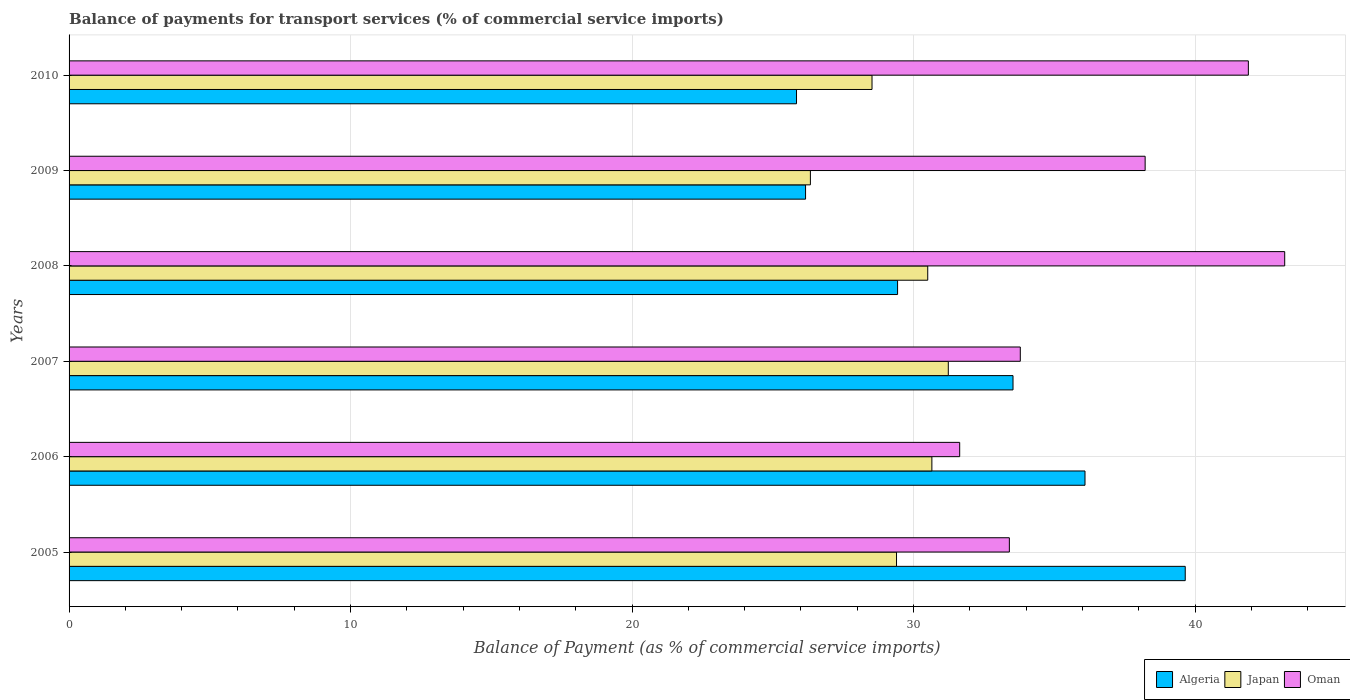How many different coloured bars are there?
Provide a short and direct response. 3. Are the number of bars on each tick of the Y-axis equal?
Offer a terse response. Yes. What is the label of the 1st group of bars from the top?
Ensure brevity in your answer.  2010. What is the balance of payments for transport services in Oman in 2010?
Offer a terse response. 41.89. Across all years, what is the maximum balance of payments for transport services in Oman?
Give a very brief answer. 43.19. Across all years, what is the minimum balance of payments for transport services in Algeria?
Provide a short and direct response. 25.84. In which year was the balance of payments for transport services in Oman minimum?
Your answer should be compact. 2006. What is the total balance of payments for transport services in Oman in the graph?
Your answer should be compact. 222.14. What is the difference between the balance of payments for transport services in Japan in 2006 and that in 2010?
Provide a short and direct response. 2.13. What is the difference between the balance of payments for transport services in Oman in 2005 and the balance of payments for transport services in Japan in 2008?
Give a very brief answer. 2.9. What is the average balance of payments for transport services in Algeria per year?
Make the answer very short. 31.79. In the year 2007, what is the difference between the balance of payments for transport services in Oman and balance of payments for transport services in Algeria?
Ensure brevity in your answer.  0.26. In how many years, is the balance of payments for transport services in Japan greater than 30 %?
Ensure brevity in your answer.  3. What is the ratio of the balance of payments for transport services in Algeria in 2005 to that in 2007?
Keep it short and to the point. 1.18. Is the difference between the balance of payments for transport services in Oman in 2007 and 2008 greater than the difference between the balance of payments for transport services in Algeria in 2007 and 2008?
Provide a short and direct response. No. What is the difference between the highest and the second highest balance of payments for transport services in Japan?
Provide a succinct answer. 0.58. What is the difference between the highest and the lowest balance of payments for transport services in Oman?
Make the answer very short. 11.55. Is the sum of the balance of payments for transport services in Oman in 2009 and 2010 greater than the maximum balance of payments for transport services in Algeria across all years?
Your answer should be very brief. Yes. What does the 1st bar from the top in 2010 represents?
Your answer should be very brief. Oman. What does the 3rd bar from the bottom in 2008 represents?
Your response must be concise. Oman. Are the values on the major ticks of X-axis written in scientific E-notation?
Provide a short and direct response. No. Does the graph contain any zero values?
Ensure brevity in your answer.  No. Does the graph contain grids?
Ensure brevity in your answer.  Yes. Where does the legend appear in the graph?
Make the answer very short. Bottom right. How many legend labels are there?
Ensure brevity in your answer.  3. How are the legend labels stacked?
Offer a very short reply. Horizontal. What is the title of the graph?
Provide a succinct answer. Balance of payments for transport services (% of commercial service imports). Does "Cote d'Ivoire" appear as one of the legend labels in the graph?
Ensure brevity in your answer.  No. What is the label or title of the X-axis?
Your answer should be compact. Balance of Payment (as % of commercial service imports). What is the label or title of the Y-axis?
Make the answer very short. Years. What is the Balance of Payment (as % of commercial service imports) of Algeria in 2005?
Provide a succinct answer. 39.65. What is the Balance of Payment (as % of commercial service imports) of Japan in 2005?
Ensure brevity in your answer.  29.4. What is the Balance of Payment (as % of commercial service imports) in Oman in 2005?
Your response must be concise. 33.4. What is the Balance of Payment (as % of commercial service imports) of Algeria in 2006?
Offer a very short reply. 36.09. What is the Balance of Payment (as % of commercial service imports) of Japan in 2006?
Offer a terse response. 30.65. What is the Balance of Payment (as % of commercial service imports) in Oman in 2006?
Keep it short and to the point. 31.64. What is the Balance of Payment (as % of commercial service imports) of Algeria in 2007?
Give a very brief answer. 33.53. What is the Balance of Payment (as % of commercial service imports) in Japan in 2007?
Your response must be concise. 31.23. What is the Balance of Payment (as % of commercial service imports) in Oman in 2007?
Offer a terse response. 33.79. What is the Balance of Payment (as % of commercial service imports) in Algeria in 2008?
Your answer should be very brief. 29.43. What is the Balance of Payment (as % of commercial service imports) in Japan in 2008?
Your answer should be very brief. 30.5. What is the Balance of Payment (as % of commercial service imports) of Oman in 2008?
Your answer should be compact. 43.19. What is the Balance of Payment (as % of commercial service imports) of Algeria in 2009?
Keep it short and to the point. 26.16. What is the Balance of Payment (as % of commercial service imports) in Japan in 2009?
Give a very brief answer. 26.34. What is the Balance of Payment (as % of commercial service imports) in Oman in 2009?
Your answer should be compact. 38.23. What is the Balance of Payment (as % of commercial service imports) in Algeria in 2010?
Offer a very short reply. 25.84. What is the Balance of Payment (as % of commercial service imports) in Japan in 2010?
Offer a terse response. 28.52. What is the Balance of Payment (as % of commercial service imports) in Oman in 2010?
Your response must be concise. 41.89. Across all years, what is the maximum Balance of Payment (as % of commercial service imports) in Algeria?
Give a very brief answer. 39.65. Across all years, what is the maximum Balance of Payment (as % of commercial service imports) of Japan?
Your answer should be compact. 31.23. Across all years, what is the maximum Balance of Payment (as % of commercial service imports) of Oman?
Offer a very short reply. 43.19. Across all years, what is the minimum Balance of Payment (as % of commercial service imports) in Algeria?
Provide a short and direct response. 25.84. Across all years, what is the minimum Balance of Payment (as % of commercial service imports) of Japan?
Offer a very short reply. 26.34. Across all years, what is the minimum Balance of Payment (as % of commercial service imports) of Oman?
Your answer should be compact. 31.64. What is the total Balance of Payment (as % of commercial service imports) of Algeria in the graph?
Your answer should be very brief. 190.72. What is the total Balance of Payment (as % of commercial service imports) of Japan in the graph?
Your response must be concise. 176.65. What is the total Balance of Payment (as % of commercial service imports) in Oman in the graph?
Offer a terse response. 222.14. What is the difference between the Balance of Payment (as % of commercial service imports) in Algeria in 2005 and that in 2006?
Provide a succinct answer. 3.56. What is the difference between the Balance of Payment (as % of commercial service imports) in Japan in 2005 and that in 2006?
Ensure brevity in your answer.  -1.26. What is the difference between the Balance of Payment (as % of commercial service imports) in Oman in 2005 and that in 2006?
Your answer should be compact. 1.76. What is the difference between the Balance of Payment (as % of commercial service imports) of Algeria in 2005 and that in 2007?
Provide a succinct answer. 6.12. What is the difference between the Balance of Payment (as % of commercial service imports) in Japan in 2005 and that in 2007?
Your answer should be very brief. -1.84. What is the difference between the Balance of Payment (as % of commercial service imports) in Oman in 2005 and that in 2007?
Ensure brevity in your answer.  -0.39. What is the difference between the Balance of Payment (as % of commercial service imports) of Algeria in 2005 and that in 2008?
Provide a succinct answer. 10.22. What is the difference between the Balance of Payment (as % of commercial service imports) in Japan in 2005 and that in 2008?
Provide a short and direct response. -1.11. What is the difference between the Balance of Payment (as % of commercial service imports) in Oman in 2005 and that in 2008?
Keep it short and to the point. -9.78. What is the difference between the Balance of Payment (as % of commercial service imports) of Algeria in 2005 and that in 2009?
Provide a short and direct response. 13.49. What is the difference between the Balance of Payment (as % of commercial service imports) of Japan in 2005 and that in 2009?
Give a very brief answer. 3.06. What is the difference between the Balance of Payment (as % of commercial service imports) of Oman in 2005 and that in 2009?
Your answer should be compact. -4.82. What is the difference between the Balance of Payment (as % of commercial service imports) of Algeria in 2005 and that in 2010?
Keep it short and to the point. 13.81. What is the difference between the Balance of Payment (as % of commercial service imports) in Japan in 2005 and that in 2010?
Your answer should be very brief. 0.87. What is the difference between the Balance of Payment (as % of commercial service imports) of Oman in 2005 and that in 2010?
Ensure brevity in your answer.  -8.49. What is the difference between the Balance of Payment (as % of commercial service imports) of Algeria in 2006 and that in 2007?
Give a very brief answer. 2.56. What is the difference between the Balance of Payment (as % of commercial service imports) in Japan in 2006 and that in 2007?
Provide a succinct answer. -0.58. What is the difference between the Balance of Payment (as % of commercial service imports) in Oman in 2006 and that in 2007?
Provide a short and direct response. -2.15. What is the difference between the Balance of Payment (as % of commercial service imports) of Algeria in 2006 and that in 2008?
Ensure brevity in your answer.  6.66. What is the difference between the Balance of Payment (as % of commercial service imports) in Japan in 2006 and that in 2008?
Your answer should be very brief. 0.15. What is the difference between the Balance of Payment (as % of commercial service imports) in Oman in 2006 and that in 2008?
Offer a terse response. -11.55. What is the difference between the Balance of Payment (as % of commercial service imports) in Algeria in 2006 and that in 2009?
Your response must be concise. 9.93. What is the difference between the Balance of Payment (as % of commercial service imports) in Japan in 2006 and that in 2009?
Your answer should be very brief. 4.32. What is the difference between the Balance of Payment (as % of commercial service imports) of Oman in 2006 and that in 2009?
Your response must be concise. -6.59. What is the difference between the Balance of Payment (as % of commercial service imports) of Algeria in 2006 and that in 2010?
Make the answer very short. 10.25. What is the difference between the Balance of Payment (as % of commercial service imports) in Japan in 2006 and that in 2010?
Your answer should be very brief. 2.13. What is the difference between the Balance of Payment (as % of commercial service imports) in Oman in 2006 and that in 2010?
Make the answer very short. -10.26. What is the difference between the Balance of Payment (as % of commercial service imports) of Algeria in 2007 and that in 2008?
Provide a succinct answer. 4.1. What is the difference between the Balance of Payment (as % of commercial service imports) in Japan in 2007 and that in 2008?
Your response must be concise. 0.73. What is the difference between the Balance of Payment (as % of commercial service imports) in Oman in 2007 and that in 2008?
Provide a short and direct response. -9.39. What is the difference between the Balance of Payment (as % of commercial service imports) of Algeria in 2007 and that in 2009?
Provide a succinct answer. 7.37. What is the difference between the Balance of Payment (as % of commercial service imports) of Japan in 2007 and that in 2009?
Your answer should be compact. 4.9. What is the difference between the Balance of Payment (as % of commercial service imports) in Oman in 2007 and that in 2009?
Offer a very short reply. -4.44. What is the difference between the Balance of Payment (as % of commercial service imports) of Algeria in 2007 and that in 2010?
Offer a terse response. 7.69. What is the difference between the Balance of Payment (as % of commercial service imports) in Japan in 2007 and that in 2010?
Offer a terse response. 2.71. What is the difference between the Balance of Payment (as % of commercial service imports) of Oman in 2007 and that in 2010?
Your answer should be very brief. -8.1. What is the difference between the Balance of Payment (as % of commercial service imports) of Algeria in 2008 and that in 2009?
Ensure brevity in your answer.  3.27. What is the difference between the Balance of Payment (as % of commercial service imports) of Japan in 2008 and that in 2009?
Ensure brevity in your answer.  4.17. What is the difference between the Balance of Payment (as % of commercial service imports) in Oman in 2008 and that in 2009?
Provide a succinct answer. 4.96. What is the difference between the Balance of Payment (as % of commercial service imports) in Algeria in 2008 and that in 2010?
Your answer should be compact. 3.59. What is the difference between the Balance of Payment (as % of commercial service imports) in Japan in 2008 and that in 2010?
Your answer should be compact. 1.98. What is the difference between the Balance of Payment (as % of commercial service imports) in Oman in 2008 and that in 2010?
Offer a very short reply. 1.29. What is the difference between the Balance of Payment (as % of commercial service imports) of Algeria in 2009 and that in 2010?
Your response must be concise. 0.32. What is the difference between the Balance of Payment (as % of commercial service imports) of Japan in 2009 and that in 2010?
Your answer should be compact. -2.19. What is the difference between the Balance of Payment (as % of commercial service imports) of Oman in 2009 and that in 2010?
Make the answer very short. -3.67. What is the difference between the Balance of Payment (as % of commercial service imports) in Algeria in 2005 and the Balance of Payment (as % of commercial service imports) in Japan in 2006?
Provide a short and direct response. 9. What is the difference between the Balance of Payment (as % of commercial service imports) of Algeria in 2005 and the Balance of Payment (as % of commercial service imports) of Oman in 2006?
Offer a very short reply. 8.01. What is the difference between the Balance of Payment (as % of commercial service imports) in Japan in 2005 and the Balance of Payment (as % of commercial service imports) in Oman in 2006?
Your answer should be compact. -2.24. What is the difference between the Balance of Payment (as % of commercial service imports) in Algeria in 2005 and the Balance of Payment (as % of commercial service imports) in Japan in 2007?
Your response must be concise. 8.42. What is the difference between the Balance of Payment (as % of commercial service imports) of Algeria in 2005 and the Balance of Payment (as % of commercial service imports) of Oman in 2007?
Your answer should be very brief. 5.86. What is the difference between the Balance of Payment (as % of commercial service imports) in Japan in 2005 and the Balance of Payment (as % of commercial service imports) in Oman in 2007?
Your answer should be very brief. -4.4. What is the difference between the Balance of Payment (as % of commercial service imports) in Algeria in 2005 and the Balance of Payment (as % of commercial service imports) in Japan in 2008?
Make the answer very short. 9.15. What is the difference between the Balance of Payment (as % of commercial service imports) in Algeria in 2005 and the Balance of Payment (as % of commercial service imports) in Oman in 2008?
Ensure brevity in your answer.  -3.53. What is the difference between the Balance of Payment (as % of commercial service imports) of Japan in 2005 and the Balance of Payment (as % of commercial service imports) of Oman in 2008?
Provide a short and direct response. -13.79. What is the difference between the Balance of Payment (as % of commercial service imports) in Algeria in 2005 and the Balance of Payment (as % of commercial service imports) in Japan in 2009?
Give a very brief answer. 13.32. What is the difference between the Balance of Payment (as % of commercial service imports) of Algeria in 2005 and the Balance of Payment (as % of commercial service imports) of Oman in 2009?
Offer a very short reply. 1.42. What is the difference between the Balance of Payment (as % of commercial service imports) of Japan in 2005 and the Balance of Payment (as % of commercial service imports) of Oman in 2009?
Your response must be concise. -8.83. What is the difference between the Balance of Payment (as % of commercial service imports) of Algeria in 2005 and the Balance of Payment (as % of commercial service imports) of Japan in 2010?
Provide a succinct answer. 11.13. What is the difference between the Balance of Payment (as % of commercial service imports) in Algeria in 2005 and the Balance of Payment (as % of commercial service imports) in Oman in 2010?
Your answer should be very brief. -2.24. What is the difference between the Balance of Payment (as % of commercial service imports) of Japan in 2005 and the Balance of Payment (as % of commercial service imports) of Oman in 2010?
Keep it short and to the point. -12.5. What is the difference between the Balance of Payment (as % of commercial service imports) in Algeria in 2006 and the Balance of Payment (as % of commercial service imports) in Japan in 2007?
Offer a very short reply. 4.86. What is the difference between the Balance of Payment (as % of commercial service imports) in Algeria in 2006 and the Balance of Payment (as % of commercial service imports) in Oman in 2007?
Your answer should be very brief. 2.3. What is the difference between the Balance of Payment (as % of commercial service imports) in Japan in 2006 and the Balance of Payment (as % of commercial service imports) in Oman in 2007?
Offer a terse response. -3.14. What is the difference between the Balance of Payment (as % of commercial service imports) of Algeria in 2006 and the Balance of Payment (as % of commercial service imports) of Japan in 2008?
Make the answer very short. 5.59. What is the difference between the Balance of Payment (as % of commercial service imports) of Algeria in 2006 and the Balance of Payment (as % of commercial service imports) of Oman in 2008?
Make the answer very short. -7.09. What is the difference between the Balance of Payment (as % of commercial service imports) of Japan in 2006 and the Balance of Payment (as % of commercial service imports) of Oman in 2008?
Make the answer very short. -12.53. What is the difference between the Balance of Payment (as % of commercial service imports) in Algeria in 2006 and the Balance of Payment (as % of commercial service imports) in Japan in 2009?
Offer a very short reply. 9.76. What is the difference between the Balance of Payment (as % of commercial service imports) of Algeria in 2006 and the Balance of Payment (as % of commercial service imports) of Oman in 2009?
Your response must be concise. -2.14. What is the difference between the Balance of Payment (as % of commercial service imports) in Japan in 2006 and the Balance of Payment (as % of commercial service imports) in Oman in 2009?
Provide a short and direct response. -7.58. What is the difference between the Balance of Payment (as % of commercial service imports) of Algeria in 2006 and the Balance of Payment (as % of commercial service imports) of Japan in 2010?
Offer a terse response. 7.57. What is the difference between the Balance of Payment (as % of commercial service imports) in Algeria in 2006 and the Balance of Payment (as % of commercial service imports) in Oman in 2010?
Keep it short and to the point. -5.8. What is the difference between the Balance of Payment (as % of commercial service imports) in Japan in 2006 and the Balance of Payment (as % of commercial service imports) in Oman in 2010?
Make the answer very short. -11.24. What is the difference between the Balance of Payment (as % of commercial service imports) of Algeria in 2007 and the Balance of Payment (as % of commercial service imports) of Japan in 2008?
Provide a succinct answer. 3.03. What is the difference between the Balance of Payment (as % of commercial service imports) in Algeria in 2007 and the Balance of Payment (as % of commercial service imports) in Oman in 2008?
Provide a succinct answer. -9.65. What is the difference between the Balance of Payment (as % of commercial service imports) of Japan in 2007 and the Balance of Payment (as % of commercial service imports) of Oman in 2008?
Your answer should be very brief. -11.95. What is the difference between the Balance of Payment (as % of commercial service imports) of Algeria in 2007 and the Balance of Payment (as % of commercial service imports) of Japan in 2009?
Provide a succinct answer. 7.2. What is the difference between the Balance of Payment (as % of commercial service imports) of Algeria in 2007 and the Balance of Payment (as % of commercial service imports) of Oman in 2009?
Your response must be concise. -4.69. What is the difference between the Balance of Payment (as % of commercial service imports) of Japan in 2007 and the Balance of Payment (as % of commercial service imports) of Oman in 2009?
Give a very brief answer. -6.99. What is the difference between the Balance of Payment (as % of commercial service imports) in Algeria in 2007 and the Balance of Payment (as % of commercial service imports) in Japan in 2010?
Offer a terse response. 5.01. What is the difference between the Balance of Payment (as % of commercial service imports) in Algeria in 2007 and the Balance of Payment (as % of commercial service imports) in Oman in 2010?
Your answer should be compact. -8.36. What is the difference between the Balance of Payment (as % of commercial service imports) of Japan in 2007 and the Balance of Payment (as % of commercial service imports) of Oman in 2010?
Provide a short and direct response. -10.66. What is the difference between the Balance of Payment (as % of commercial service imports) of Algeria in 2008 and the Balance of Payment (as % of commercial service imports) of Japan in 2009?
Ensure brevity in your answer.  3.1. What is the difference between the Balance of Payment (as % of commercial service imports) in Algeria in 2008 and the Balance of Payment (as % of commercial service imports) in Oman in 2009?
Your response must be concise. -8.8. What is the difference between the Balance of Payment (as % of commercial service imports) in Japan in 2008 and the Balance of Payment (as % of commercial service imports) in Oman in 2009?
Keep it short and to the point. -7.72. What is the difference between the Balance of Payment (as % of commercial service imports) in Algeria in 2008 and the Balance of Payment (as % of commercial service imports) in Japan in 2010?
Ensure brevity in your answer.  0.91. What is the difference between the Balance of Payment (as % of commercial service imports) in Algeria in 2008 and the Balance of Payment (as % of commercial service imports) in Oman in 2010?
Give a very brief answer. -12.46. What is the difference between the Balance of Payment (as % of commercial service imports) of Japan in 2008 and the Balance of Payment (as % of commercial service imports) of Oman in 2010?
Offer a very short reply. -11.39. What is the difference between the Balance of Payment (as % of commercial service imports) in Algeria in 2009 and the Balance of Payment (as % of commercial service imports) in Japan in 2010?
Provide a short and direct response. -2.36. What is the difference between the Balance of Payment (as % of commercial service imports) in Algeria in 2009 and the Balance of Payment (as % of commercial service imports) in Oman in 2010?
Provide a succinct answer. -15.73. What is the difference between the Balance of Payment (as % of commercial service imports) of Japan in 2009 and the Balance of Payment (as % of commercial service imports) of Oman in 2010?
Ensure brevity in your answer.  -15.56. What is the average Balance of Payment (as % of commercial service imports) of Algeria per year?
Ensure brevity in your answer.  31.79. What is the average Balance of Payment (as % of commercial service imports) of Japan per year?
Your response must be concise. 29.44. What is the average Balance of Payment (as % of commercial service imports) of Oman per year?
Offer a very short reply. 37.02. In the year 2005, what is the difference between the Balance of Payment (as % of commercial service imports) in Algeria and Balance of Payment (as % of commercial service imports) in Japan?
Provide a succinct answer. 10.26. In the year 2005, what is the difference between the Balance of Payment (as % of commercial service imports) of Algeria and Balance of Payment (as % of commercial service imports) of Oman?
Keep it short and to the point. 6.25. In the year 2005, what is the difference between the Balance of Payment (as % of commercial service imports) of Japan and Balance of Payment (as % of commercial service imports) of Oman?
Provide a short and direct response. -4.01. In the year 2006, what is the difference between the Balance of Payment (as % of commercial service imports) in Algeria and Balance of Payment (as % of commercial service imports) in Japan?
Your answer should be compact. 5.44. In the year 2006, what is the difference between the Balance of Payment (as % of commercial service imports) in Algeria and Balance of Payment (as % of commercial service imports) in Oman?
Your answer should be very brief. 4.45. In the year 2006, what is the difference between the Balance of Payment (as % of commercial service imports) in Japan and Balance of Payment (as % of commercial service imports) in Oman?
Provide a succinct answer. -0.99. In the year 2007, what is the difference between the Balance of Payment (as % of commercial service imports) in Algeria and Balance of Payment (as % of commercial service imports) in Japan?
Offer a very short reply. 2.3. In the year 2007, what is the difference between the Balance of Payment (as % of commercial service imports) in Algeria and Balance of Payment (as % of commercial service imports) in Oman?
Offer a terse response. -0.26. In the year 2007, what is the difference between the Balance of Payment (as % of commercial service imports) in Japan and Balance of Payment (as % of commercial service imports) in Oman?
Give a very brief answer. -2.56. In the year 2008, what is the difference between the Balance of Payment (as % of commercial service imports) in Algeria and Balance of Payment (as % of commercial service imports) in Japan?
Your answer should be compact. -1.07. In the year 2008, what is the difference between the Balance of Payment (as % of commercial service imports) in Algeria and Balance of Payment (as % of commercial service imports) in Oman?
Give a very brief answer. -13.75. In the year 2008, what is the difference between the Balance of Payment (as % of commercial service imports) in Japan and Balance of Payment (as % of commercial service imports) in Oman?
Keep it short and to the point. -12.68. In the year 2009, what is the difference between the Balance of Payment (as % of commercial service imports) of Algeria and Balance of Payment (as % of commercial service imports) of Japan?
Your answer should be very brief. -0.17. In the year 2009, what is the difference between the Balance of Payment (as % of commercial service imports) in Algeria and Balance of Payment (as % of commercial service imports) in Oman?
Your answer should be very brief. -12.06. In the year 2009, what is the difference between the Balance of Payment (as % of commercial service imports) in Japan and Balance of Payment (as % of commercial service imports) in Oman?
Ensure brevity in your answer.  -11.89. In the year 2010, what is the difference between the Balance of Payment (as % of commercial service imports) of Algeria and Balance of Payment (as % of commercial service imports) of Japan?
Make the answer very short. -2.68. In the year 2010, what is the difference between the Balance of Payment (as % of commercial service imports) of Algeria and Balance of Payment (as % of commercial service imports) of Oman?
Ensure brevity in your answer.  -16.05. In the year 2010, what is the difference between the Balance of Payment (as % of commercial service imports) of Japan and Balance of Payment (as % of commercial service imports) of Oman?
Make the answer very short. -13.37. What is the ratio of the Balance of Payment (as % of commercial service imports) of Algeria in 2005 to that in 2006?
Your response must be concise. 1.1. What is the ratio of the Balance of Payment (as % of commercial service imports) in Oman in 2005 to that in 2006?
Your answer should be very brief. 1.06. What is the ratio of the Balance of Payment (as % of commercial service imports) in Algeria in 2005 to that in 2007?
Offer a terse response. 1.18. What is the ratio of the Balance of Payment (as % of commercial service imports) in Japan in 2005 to that in 2007?
Your answer should be very brief. 0.94. What is the ratio of the Balance of Payment (as % of commercial service imports) of Algeria in 2005 to that in 2008?
Your answer should be compact. 1.35. What is the ratio of the Balance of Payment (as % of commercial service imports) in Japan in 2005 to that in 2008?
Your response must be concise. 0.96. What is the ratio of the Balance of Payment (as % of commercial service imports) of Oman in 2005 to that in 2008?
Keep it short and to the point. 0.77. What is the ratio of the Balance of Payment (as % of commercial service imports) in Algeria in 2005 to that in 2009?
Provide a succinct answer. 1.52. What is the ratio of the Balance of Payment (as % of commercial service imports) of Japan in 2005 to that in 2009?
Give a very brief answer. 1.12. What is the ratio of the Balance of Payment (as % of commercial service imports) in Oman in 2005 to that in 2009?
Provide a short and direct response. 0.87. What is the ratio of the Balance of Payment (as % of commercial service imports) in Algeria in 2005 to that in 2010?
Provide a short and direct response. 1.53. What is the ratio of the Balance of Payment (as % of commercial service imports) in Japan in 2005 to that in 2010?
Your response must be concise. 1.03. What is the ratio of the Balance of Payment (as % of commercial service imports) in Oman in 2005 to that in 2010?
Ensure brevity in your answer.  0.8. What is the ratio of the Balance of Payment (as % of commercial service imports) of Algeria in 2006 to that in 2007?
Give a very brief answer. 1.08. What is the ratio of the Balance of Payment (as % of commercial service imports) in Japan in 2006 to that in 2007?
Your response must be concise. 0.98. What is the ratio of the Balance of Payment (as % of commercial service imports) of Oman in 2006 to that in 2007?
Provide a short and direct response. 0.94. What is the ratio of the Balance of Payment (as % of commercial service imports) in Algeria in 2006 to that in 2008?
Provide a succinct answer. 1.23. What is the ratio of the Balance of Payment (as % of commercial service imports) in Japan in 2006 to that in 2008?
Offer a terse response. 1. What is the ratio of the Balance of Payment (as % of commercial service imports) in Oman in 2006 to that in 2008?
Make the answer very short. 0.73. What is the ratio of the Balance of Payment (as % of commercial service imports) in Algeria in 2006 to that in 2009?
Your answer should be very brief. 1.38. What is the ratio of the Balance of Payment (as % of commercial service imports) of Japan in 2006 to that in 2009?
Ensure brevity in your answer.  1.16. What is the ratio of the Balance of Payment (as % of commercial service imports) of Oman in 2006 to that in 2009?
Give a very brief answer. 0.83. What is the ratio of the Balance of Payment (as % of commercial service imports) of Algeria in 2006 to that in 2010?
Make the answer very short. 1.4. What is the ratio of the Balance of Payment (as % of commercial service imports) in Japan in 2006 to that in 2010?
Ensure brevity in your answer.  1.07. What is the ratio of the Balance of Payment (as % of commercial service imports) in Oman in 2006 to that in 2010?
Give a very brief answer. 0.76. What is the ratio of the Balance of Payment (as % of commercial service imports) of Algeria in 2007 to that in 2008?
Your response must be concise. 1.14. What is the ratio of the Balance of Payment (as % of commercial service imports) in Japan in 2007 to that in 2008?
Make the answer very short. 1.02. What is the ratio of the Balance of Payment (as % of commercial service imports) of Oman in 2007 to that in 2008?
Offer a terse response. 0.78. What is the ratio of the Balance of Payment (as % of commercial service imports) in Algeria in 2007 to that in 2009?
Make the answer very short. 1.28. What is the ratio of the Balance of Payment (as % of commercial service imports) of Japan in 2007 to that in 2009?
Provide a short and direct response. 1.19. What is the ratio of the Balance of Payment (as % of commercial service imports) in Oman in 2007 to that in 2009?
Your response must be concise. 0.88. What is the ratio of the Balance of Payment (as % of commercial service imports) in Algeria in 2007 to that in 2010?
Your response must be concise. 1.3. What is the ratio of the Balance of Payment (as % of commercial service imports) in Japan in 2007 to that in 2010?
Keep it short and to the point. 1.09. What is the ratio of the Balance of Payment (as % of commercial service imports) of Oman in 2007 to that in 2010?
Make the answer very short. 0.81. What is the ratio of the Balance of Payment (as % of commercial service imports) of Algeria in 2008 to that in 2009?
Offer a terse response. 1.12. What is the ratio of the Balance of Payment (as % of commercial service imports) of Japan in 2008 to that in 2009?
Provide a short and direct response. 1.16. What is the ratio of the Balance of Payment (as % of commercial service imports) of Oman in 2008 to that in 2009?
Your response must be concise. 1.13. What is the ratio of the Balance of Payment (as % of commercial service imports) in Algeria in 2008 to that in 2010?
Your response must be concise. 1.14. What is the ratio of the Balance of Payment (as % of commercial service imports) of Japan in 2008 to that in 2010?
Make the answer very short. 1.07. What is the ratio of the Balance of Payment (as % of commercial service imports) in Oman in 2008 to that in 2010?
Your answer should be very brief. 1.03. What is the ratio of the Balance of Payment (as % of commercial service imports) in Algeria in 2009 to that in 2010?
Offer a terse response. 1.01. What is the ratio of the Balance of Payment (as % of commercial service imports) of Japan in 2009 to that in 2010?
Your response must be concise. 0.92. What is the ratio of the Balance of Payment (as % of commercial service imports) of Oman in 2009 to that in 2010?
Give a very brief answer. 0.91. What is the difference between the highest and the second highest Balance of Payment (as % of commercial service imports) in Algeria?
Ensure brevity in your answer.  3.56. What is the difference between the highest and the second highest Balance of Payment (as % of commercial service imports) of Japan?
Ensure brevity in your answer.  0.58. What is the difference between the highest and the second highest Balance of Payment (as % of commercial service imports) in Oman?
Your answer should be very brief. 1.29. What is the difference between the highest and the lowest Balance of Payment (as % of commercial service imports) of Algeria?
Keep it short and to the point. 13.81. What is the difference between the highest and the lowest Balance of Payment (as % of commercial service imports) of Japan?
Make the answer very short. 4.9. What is the difference between the highest and the lowest Balance of Payment (as % of commercial service imports) in Oman?
Your answer should be very brief. 11.55. 